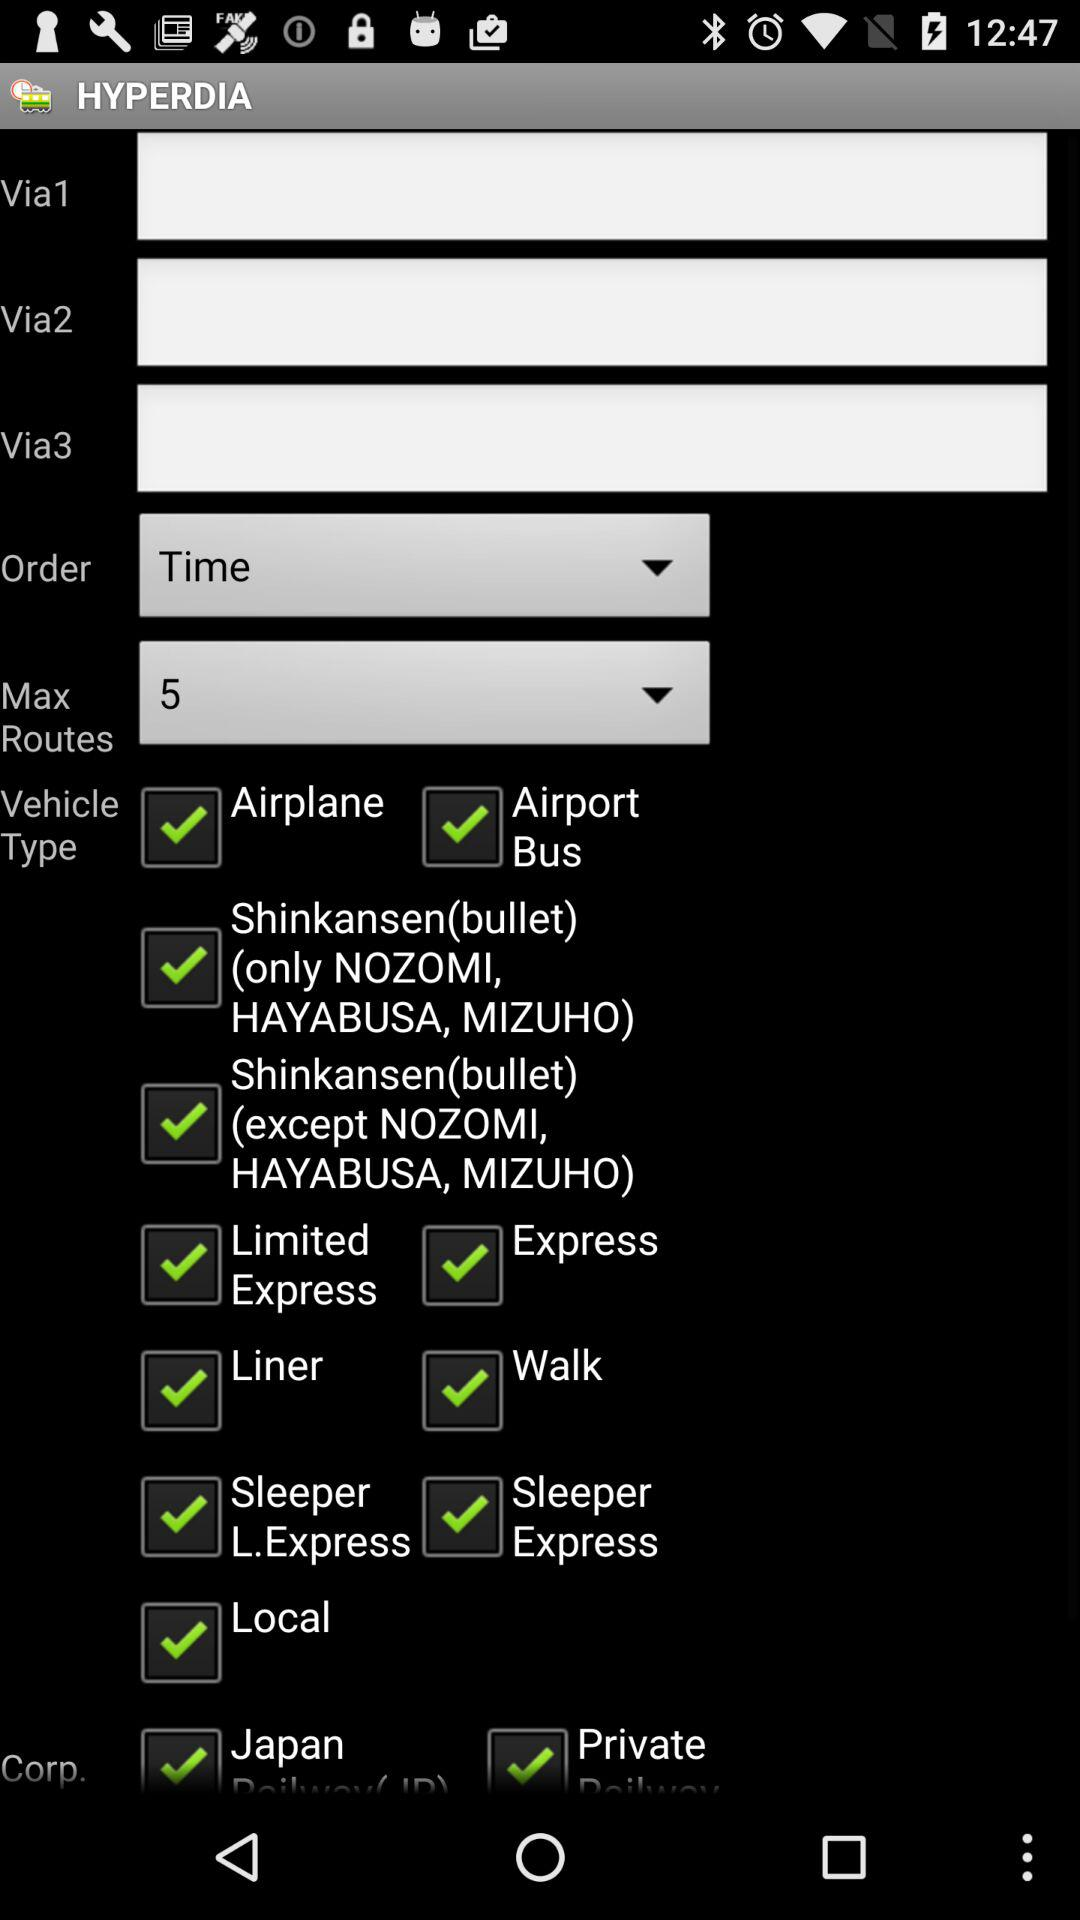What is the order? The order is time. 